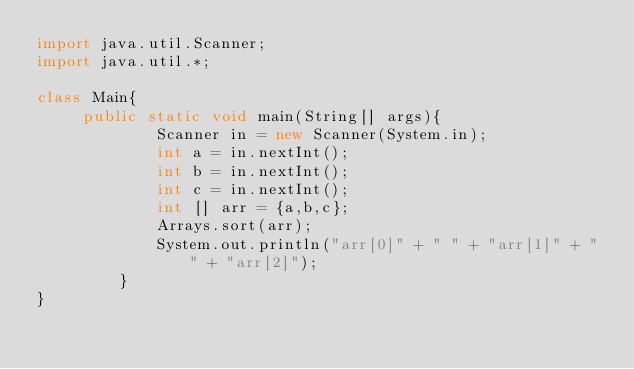Convert code to text. <code><loc_0><loc_0><loc_500><loc_500><_Java_>import java.util.Scanner;                                                   
import java.util.*;
 
class Main{
     public static void main(String[] args){
             Scanner in = new Scanner(System.in);
             int a = in.nextInt();
             int b = in.nextInt();
             int c = in.nextInt();
             int [] arr = {a,b,c};
             Arrays.sort(arr);
             System.out.println("arr[0]" + " " + "arr[1]" + " " + "arr[2]");
         }
}</code> 